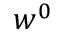<formula> <loc_0><loc_0><loc_500><loc_500>w ^ { 0 }</formula> 